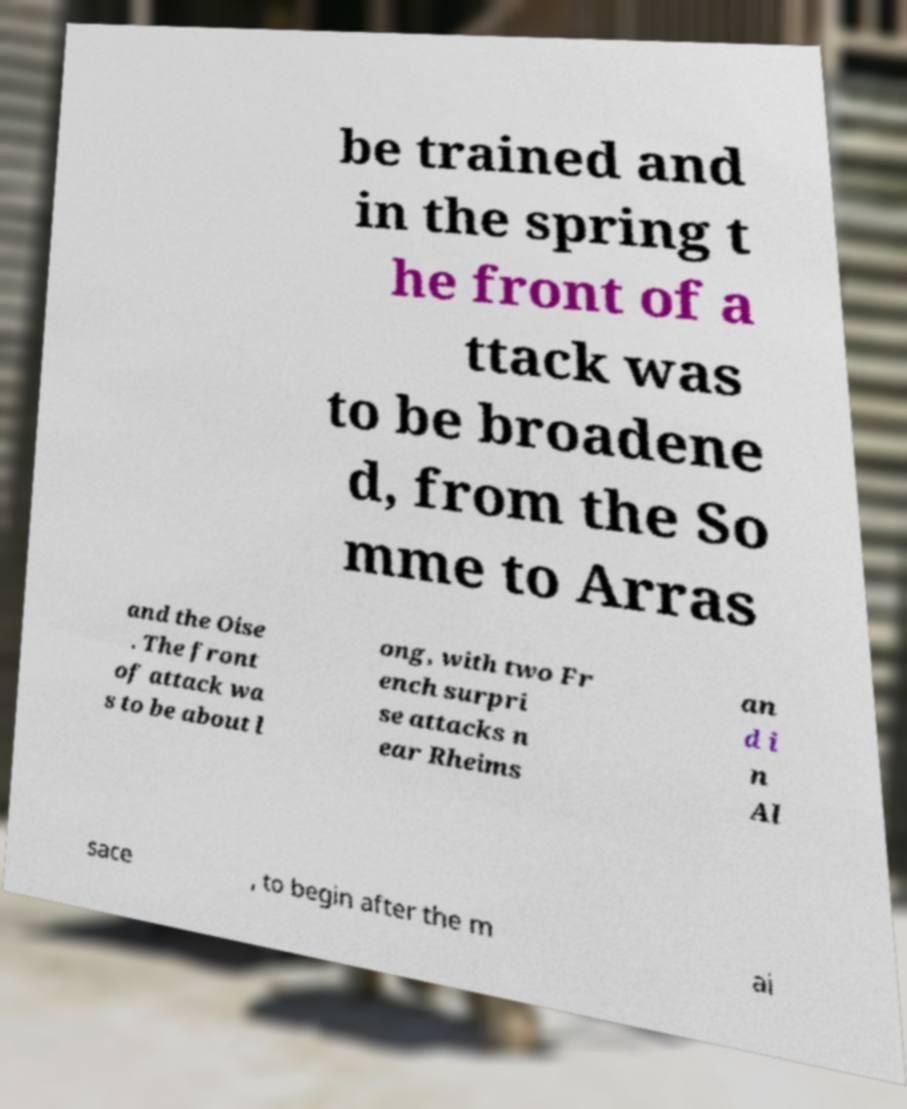Could you assist in decoding the text presented in this image and type it out clearly? be trained and in the spring t he front of a ttack was to be broadene d, from the So mme to Arras and the Oise . The front of attack wa s to be about l ong, with two Fr ench surpri se attacks n ear Rheims an d i n Al sace , to begin after the m ai 